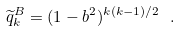<formula> <loc_0><loc_0><loc_500><loc_500>\widetilde { q } _ { k } ^ { B } = ( 1 - b ^ { 2 } ) ^ { k ( k - 1 ) / 2 } \ .</formula> 